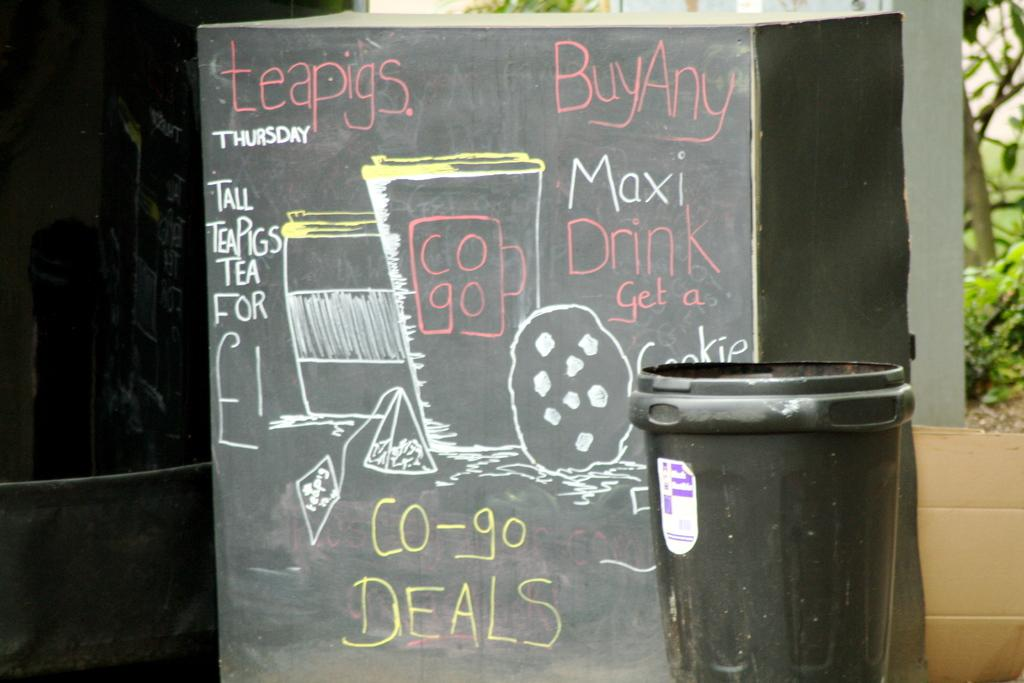<image>
Relay a brief, clear account of the picture shown. The top of a blackboard proclaims the day is teapigs Thursday. 